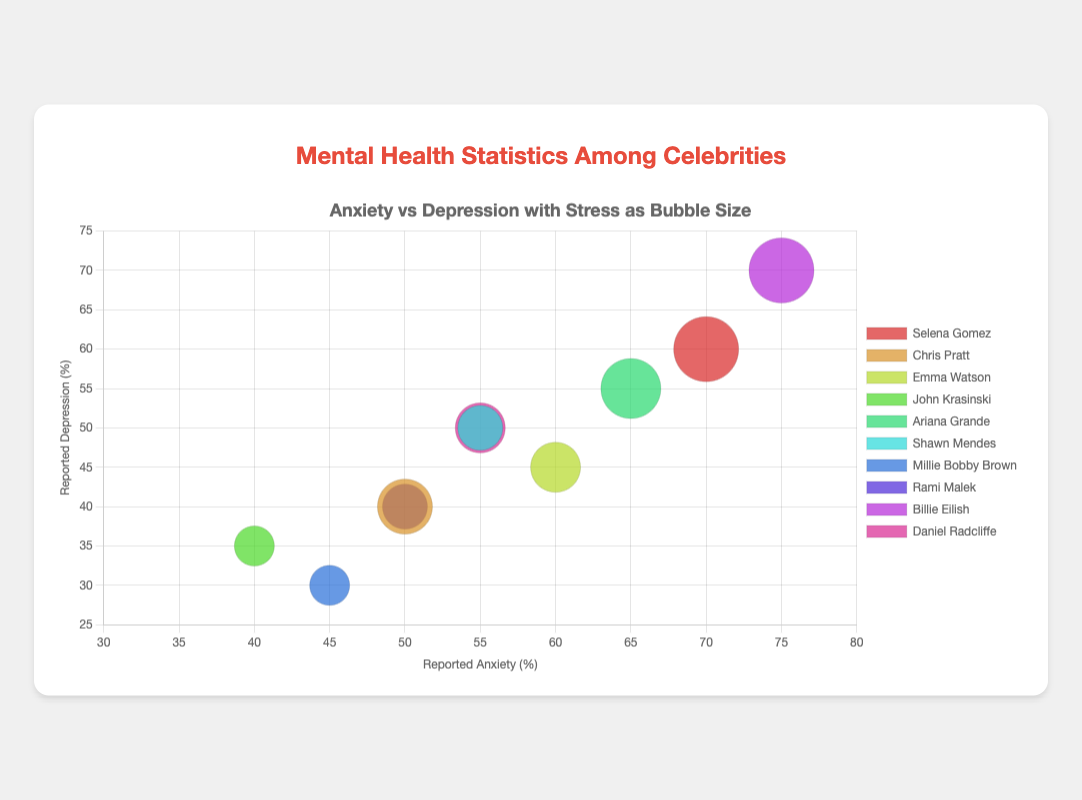What's the title at the top of the figure? The title of the figure is displayed at the top in larger font size and reads 'Mental Health Statistics Among Celebrities'.
Answer: 'Mental Health Statistics Among Celebrities' What is the label for the x-axis? The x-axis label is shown below the x-axis line and reads 'Reported Anxiety (%)'.
Answer: 'Reported Anxiety (%)' How many celebrities are plotted in the bubble chart? Each bubble corresponds to a celebrity, and we can count the total bubbles to find the number of celebrities. There are 10 celebrities in the data.
Answer: 10 Which celebrity has the highest reported depression rate? By looking at the y-values, Billie Eilish has the highest reported depression at 70%.
Answer: Billie Eilish Which celebrity has the smallest bubble size, indicating the lowest reported stress? The size of the bubble corresponds to the reported stress, and the smallest bubble is for Millie Bobby Brown with a reported stress of 40%.
Answer: Millie Bobby Brown What is the reported anxiety level for Daniel Radcliffe? The x-position of Daniel Radcliffe's bubble gives his reported anxiety level, which is 55%.
Answer: 55% Compare the reported anxiety and depression levels of Selena Gomez and Chris Pratt. Which celebrity has higher levels? Selena Gomez's reported anxiety is 70% and depression is 60%, while Chris Pratt's is 50% and 40%. Selena Gomez has higher levels of both anxiety and depression.
Answer: Selena Gomez What is the range of reported anxiety levels among all celebrities? The minimum reported anxiety level is 40% (John Krasinski), and the maximum is 75% (Billie Eilish). The range is 75% - 40% = 35%.
Answer: 35% Considering celebrities with a 'Medium' media exposure level, what is the average reported depression percentage? Add the reported depression percentages of Emma Watson (45%), John Krasinski (35%), Shawn Mendes (50%), Rami Malek (40%), and Daniel Radcliffe (50%), and divide by the number of celebrities: (45 + 35 + 50 + 40 + 50) / 5 = 44%.
Answer: 44% How does Ariana Grande's reported stress compare with the average reported stress of all celebrities? Calculate the average reported stress of all celebrities ((65 + 55 + 50 + 40 + 60 + 45 + 40 + 45 + 65 + 50) / 10 = 51.5%). Ariana Grande's reported stress is 60%, which is above the average of 51.5%.
Answer: Above average 